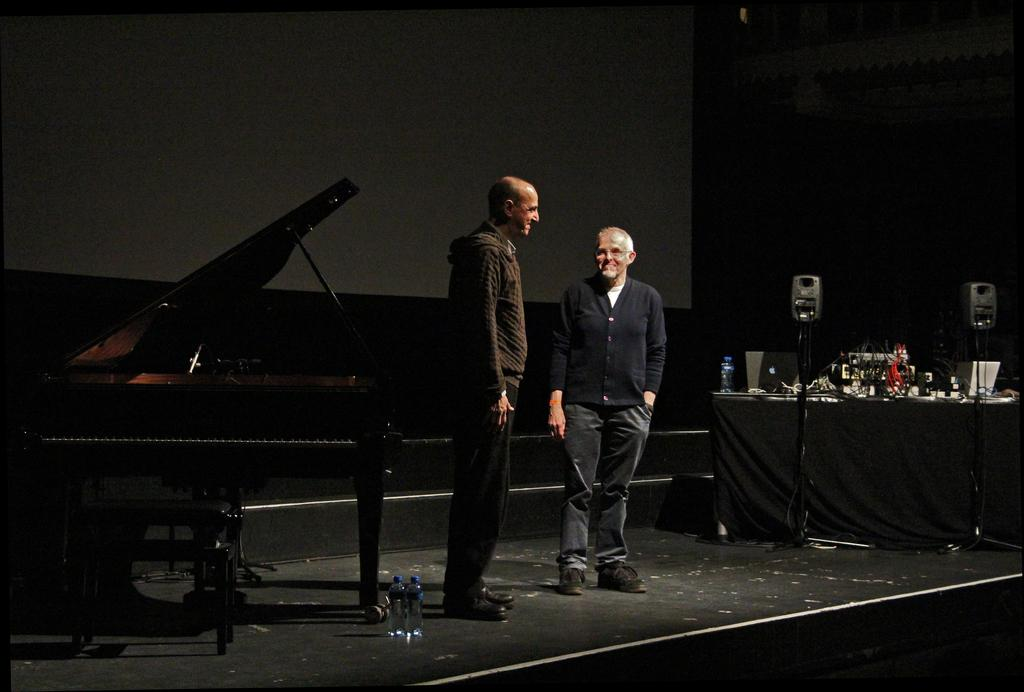How many people are in the image? There are two men in the image. Where are the men located in the image? The men are standing on a stage. What is present beside the men on the stage? There is a piano beside the men on the stage. What color is the veil worn by the expert in the image? There is no expert or veil present in the image. The image features two men standing on a stage with a piano beside them. 